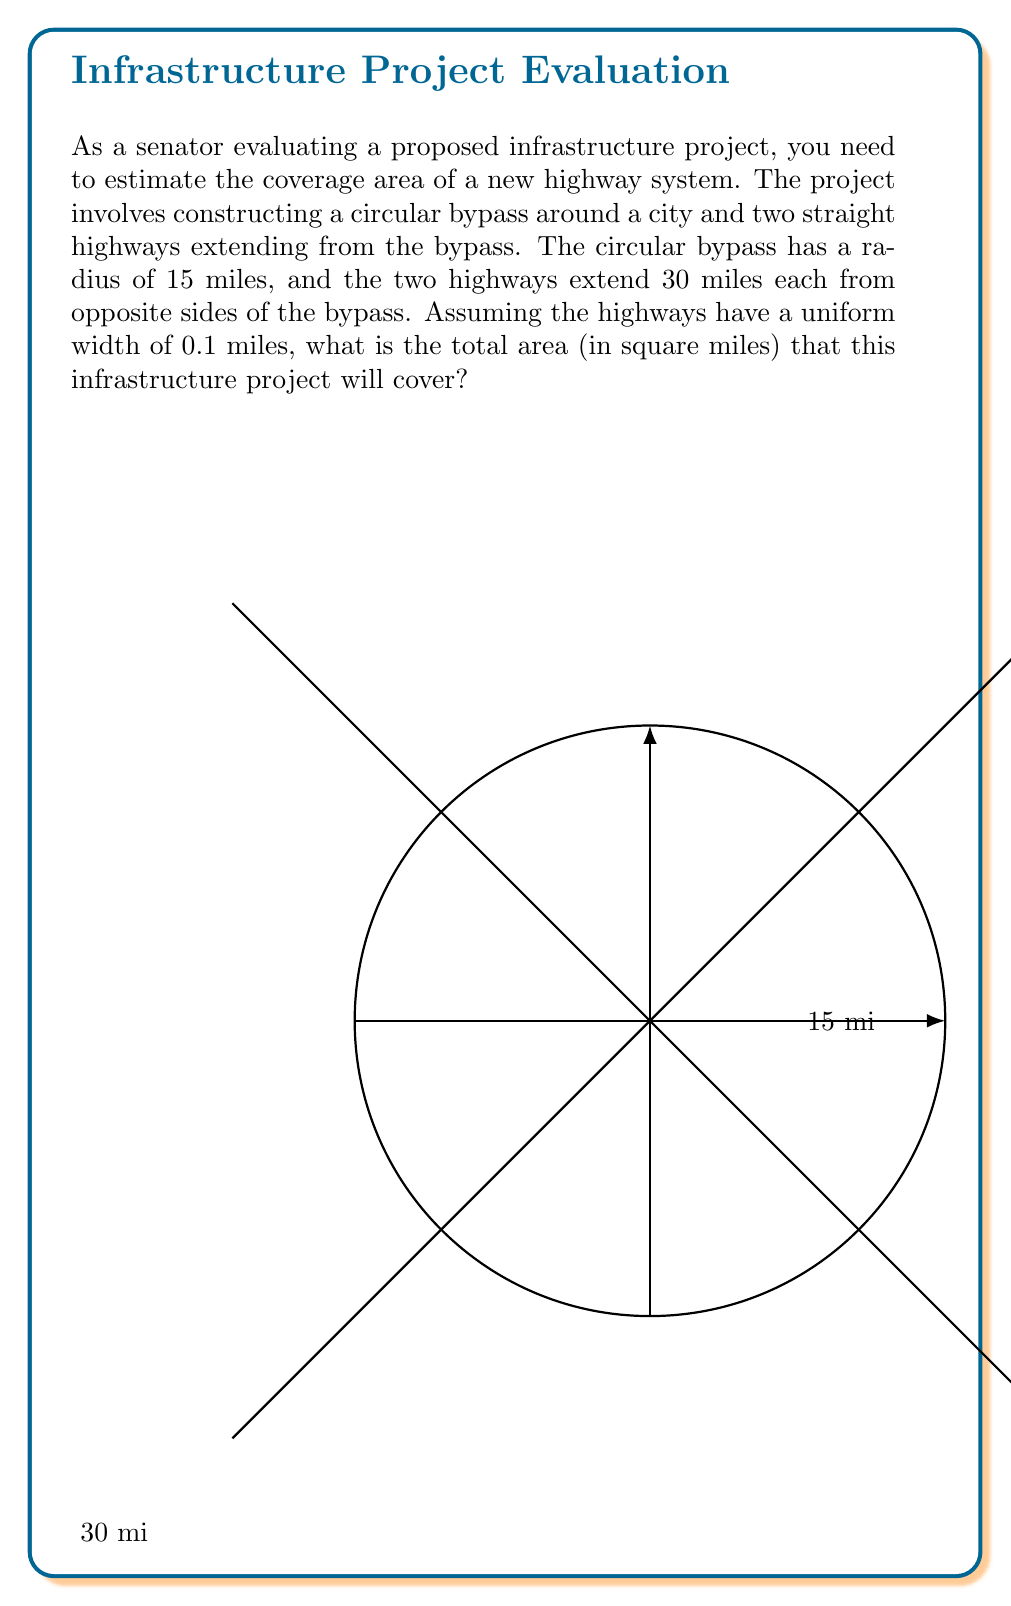Give your solution to this math problem. To solve this problem, we need to calculate the areas of the circular bypass and the two straight highways separately, then sum them up.

1. Area of the circular bypass:
   The formula for the area of a circle is $A = \pi r^2$
   $A_{\text{bypass}} = \pi \cdot 15^2 = 225\pi$ square miles

2. Area of the straight highways:
   Each highway is essentially a rectangle with length 30 miles and width 0.1 miles
   Area of one highway = $30 \cdot 0.1 = 3$ square miles
   Area of both highways = $3 \cdot 2 = 6$ square miles

3. Total area:
   $A_{\text{total}} = A_{\text{bypass}} + A_{\text{highways}}$
   $A_{\text{total}} = 225\pi + 6$ square miles

4. Simplifying:
   $A_{\text{total}} = 225\pi + 6 \approx 712.39$ square miles

Therefore, the total area covered by the infrastructure project is approximately 712.39 square miles.
Answer: $225\pi + 6 \approx 712.39$ square miles 